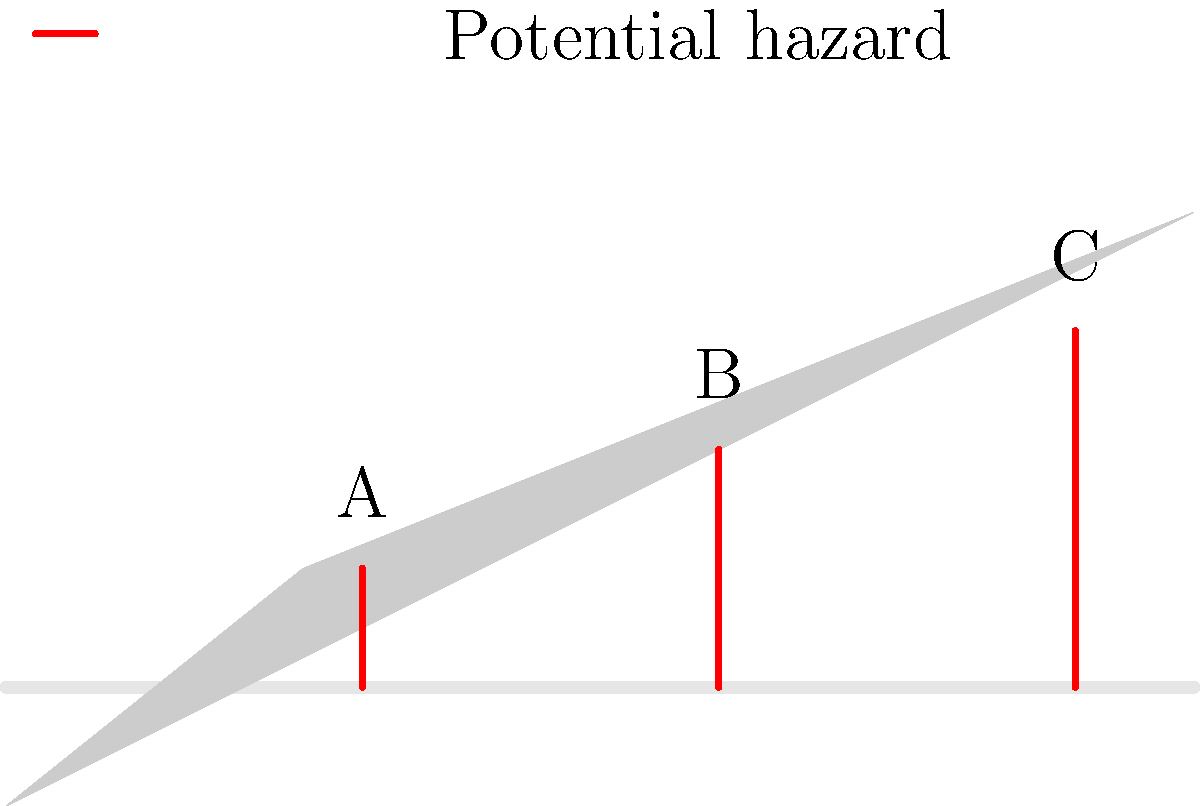In the given cross-section of a mountain road, identify the potential hazard that poses the greatest risk to drivers, considering factors such as slope steepness and proximity to the road. To identify the greatest potential hazard, we need to analyze each marked location (A, B, and C) based on two primary factors: slope steepness and proximity to the road. Let's examine each location step-by-step:

1. Location A:
   - Slope: Relatively gentle
   - Proximity to road: Close
   - Risk level: Moderate

2. Location B:
   - Slope: Steeper than A
   - Proximity to road: Moderate distance
   - Risk level: High

3. Location C:
   - Slope: Steepest of all three
   - Proximity to road: Furthest from the road
   - Risk level: Highest

Analyzing these factors:
- Steeper slopes increase the risk of landslides or rock falls.
- Closer proximity to the road means less time for drivers to react to falling debris.

While location A is closest to the road, its gentler slope reduces the risk of major landslides or rock falls.

Location B has a steeper slope and is still relatively close to the road, presenting a significant risk.

Location C, despite being the furthest from the road, has the steepest slope. This extreme steepness significantly increases the likelihood of landslides or rock falls. Even though it's further from the road, the potential volume and speed of falling debris make it the most dangerous.

Therefore, location C poses the greatest risk to drivers due to its extreme steepness, which outweighs its greater distance from the road.
Answer: Location C 